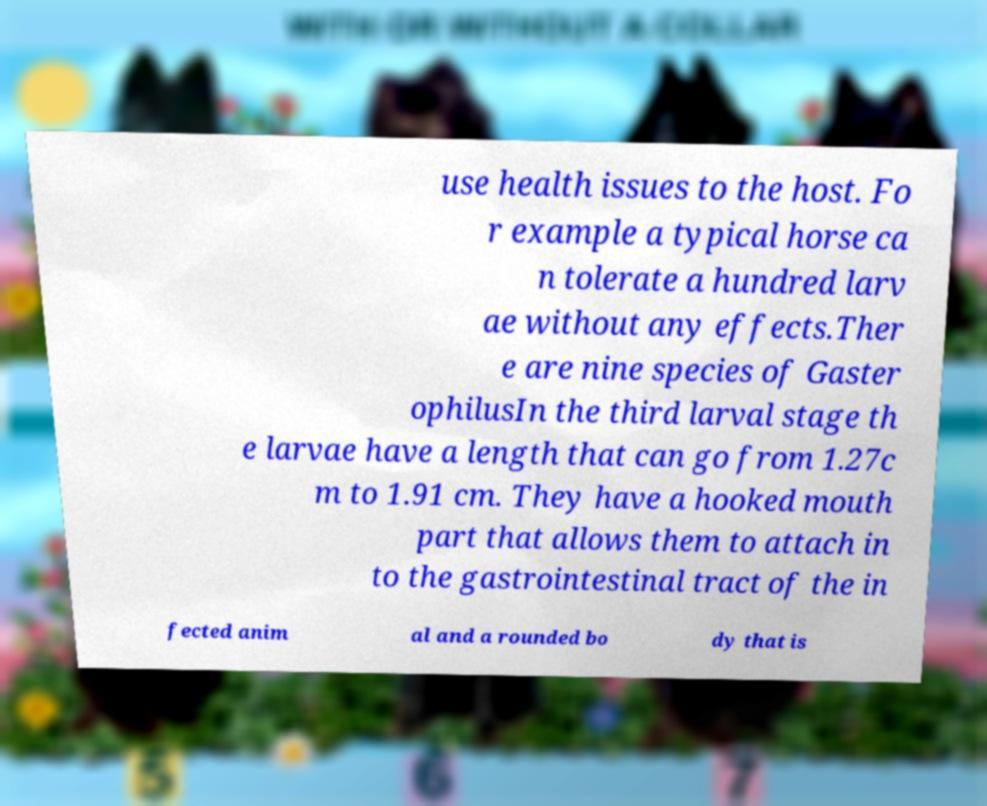Please read and relay the text visible in this image. What does it say? use health issues to the host. Fo r example a typical horse ca n tolerate a hundred larv ae without any effects.Ther e are nine species of Gaster ophilusIn the third larval stage th e larvae have a length that can go from 1.27c m to 1.91 cm. They have a hooked mouth part that allows them to attach in to the gastrointestinal tract of the in fected anim al and a rounded bo dy that is 